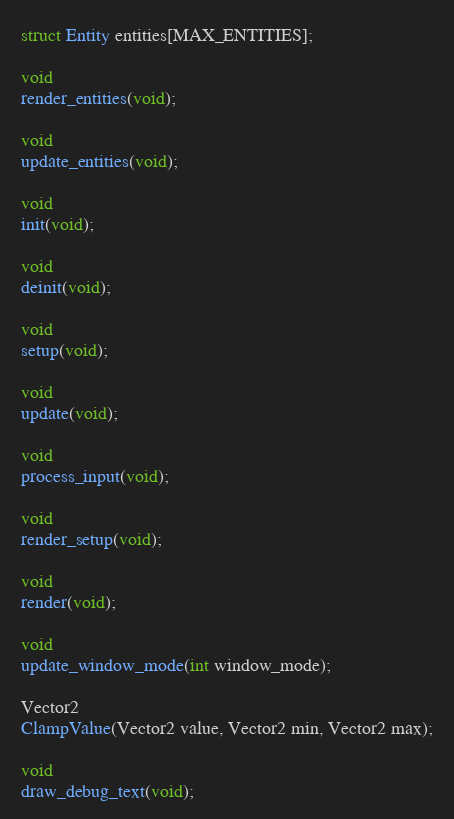Convert code to text. <code><loc_0><loc_0><loc_500><loc_500><_C_>
struct Entity entities[MAX_ENTITIES];

void
render_entities(void);

void
update_entities(void);

void
init(void);

void
deinit(void);

void
setup(void);

void
update(void);

void
process_input(void);

void
render_setup(void);

void
render(void);

void
update_window_mode(int window_mode);

Vector2
ClampValue(Vector2 value, Vector2 min, Vector2 max);

void
draw_debug_text(void);</code> 